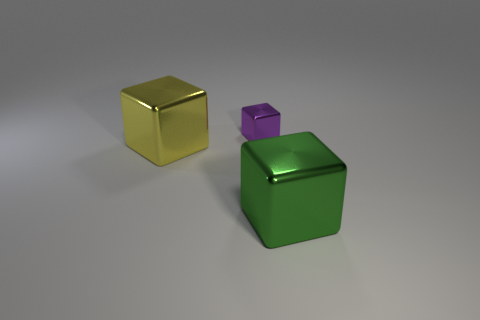Add 1 yellow objects. How many objects exist? 4 Add 3 small purple things. How many small purple things exist? 4 Subtract 0 green spheres. How many objects are left? 3 Subtract all brown metallic balls. Subtract all tiny purple metal objects. How many objects are left? 2 Add 2 big cubes. How many big cubes are left? 4 